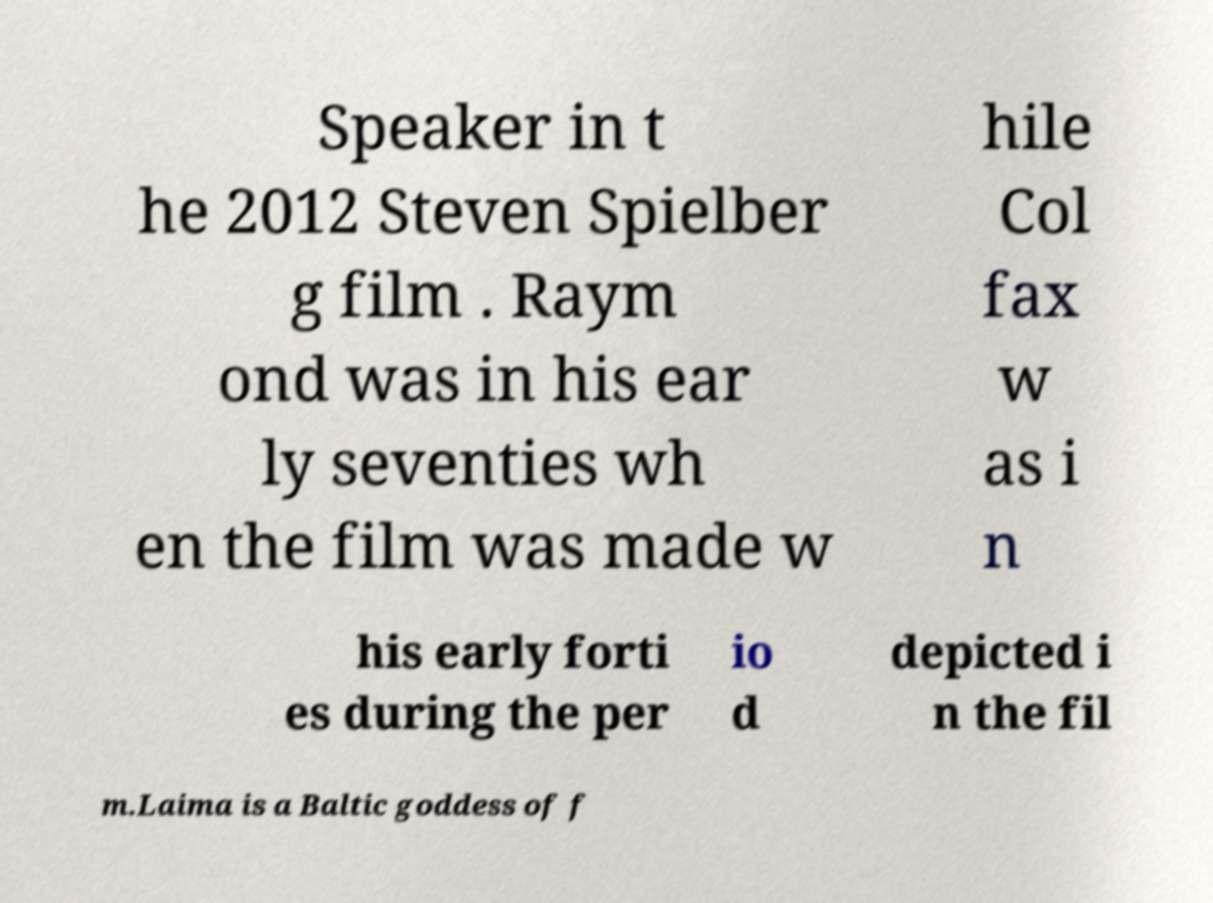Could you extract and type out the text from this image? Speaker in t he 2012 Steven Spielber g film . Raym ond was in his ear ly seventies wh en the film was made w hile Col fax w as i n his early forti es during the per io d depicted i n the fil m.Laima is a Baltic goddess of f 